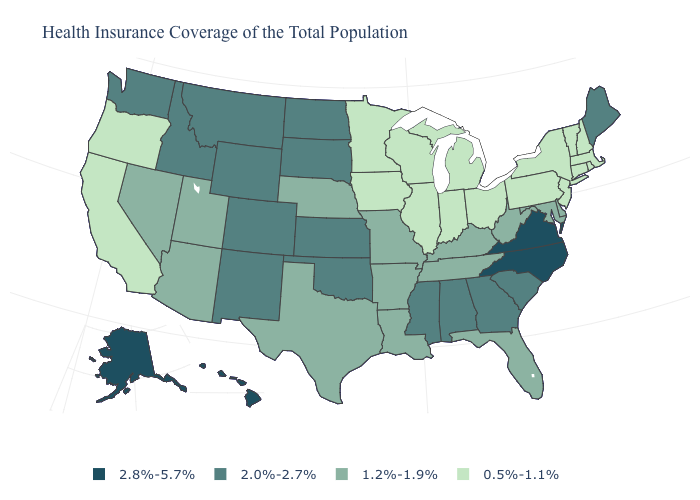Name the states that have a value in the range 0.5%-1.1%?
Give a very brief answer. California, Connecticut, Illinois, Indiana, Iowa, Massachusetts, Michigan, Minnesota, New Hampshire, New Jersey, New York, Ohio, Oregon, Pennsylvania, Rhode Island, Vermont, Wisconsin. Name the states that have a value in the range 1.2%-1.9%?
Be succinct. Arizona, Arkansas, Delaware, Florida, Kentucky, Louisiana, Maryland, Missouri, Nebraska, Nevada, Tennessee, Texas, Utah, West Virginia. Does Colorado have the same value as Alaska?
Keep it brief. No. Among the states that border Arkansas , which have the lowest value?
Keep it brief. Louisiana, Missouri, Tennessee, Texas. Among the states that border Kentucky , which have the highest value?
Write a very short answer. Virginia. What is the highest value in the USA?
Be succinct. 2.8%-5.7%. What is the value of Alaska?
Write a very short answer. 2.8%-5.7%. Does the first symbol in the legend represent the smallest category?
Short answer required. No. Name the states that have a value in the range 1.2%-1.9%?
Concise answer only. Arizona, Arkansas, Delaware, Florida, Kentucky, Louisiana, Maryland, Missouri, Nebraska, Nevada, Tennessee, Texas, Utah, West Virginia. Among the states that border Maine , which have the lowest value?
Quick response, please. New Hampshire. What is the value of Virginia?
Write a very short answer. 2.8%-5.7%. Does the map have missing data?
Concise answer only. No. What is the value of Utah?
Be succinct. 1.2%-1.9%. Name the states that have a value in the range 0.5%-1.1%?
Concise answer only. California, Connecticut, Illinois, Indiana, Iowa, Massachusetts, Michigan, Minnesota, New Hampshire, New Jersey, New York, Ohio, Oregon, Pennsylvania, Rhode Island, Vermont, Wisconsin. What is the highest value in states that border Utah?
Concise answer only. 2.0%-2.7%. 